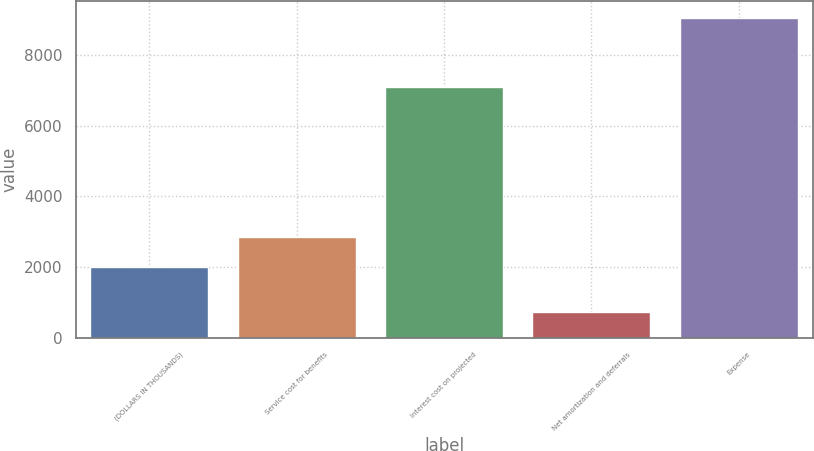Convert chart to OTSL. <chart><loc_0><loc_0><loc_500><loc_500><bar_chart><fcel>(DOLLARS IN THOUSANDS)<fcel>Service cost for benefits<fcel>Interest cost on projected<fcel>Net amortization and deferrals<fcel>Expense<nl><fcel>2008<fcel>2840.7<fcel>7079<fcel>723<fcel>9050<nl></chart> 